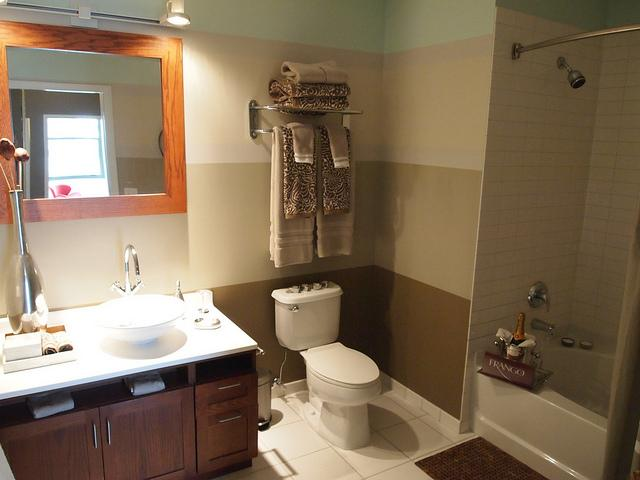What color is the border around the edges of the mirror? Please explain your reasoning. wood. The color is wood. 